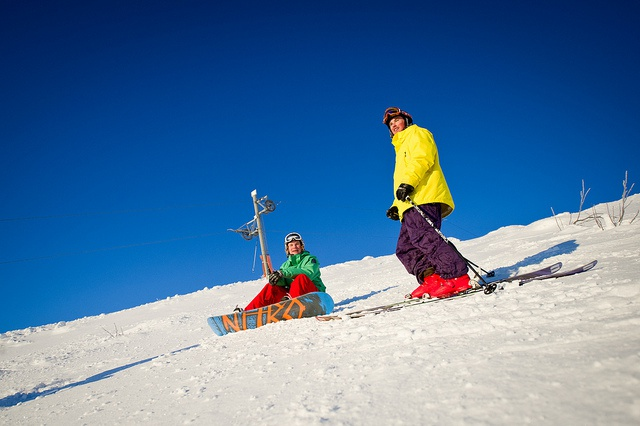Describe the objects in this image and their specific colors. I can see people in navy, black, gold, purple, and yellow tones, people in navy, red, maroon, and black tones, and snowboard in navy, gray, and orange tones in this image. 